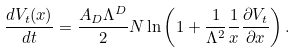<formula> <loc_0><loc_0><loc_500><loc_500>\frac { d V _ { t } ( x ) } { d t } = \frac { A _ { D } \Lambda ^ { D } } { 2 } N \ln \left ( 1 + \frac { 1 } { \Lambda ^ { 2 } } \frac { 1 } { x } \frac { \partial V _ { t } } { \partial x } \right ) .</formula> 